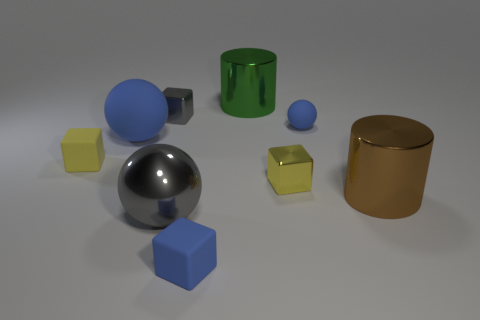Subtract 1 blocks. How many blocks are left? 3 Subtract all cylinders. How many objects are left? 7 Add 9 tiny green metallic blocks. How many tiny green metallic blocks exist? 9 Subtract 1 gray blocks. How many objects are left? 8 Subtract all blue matte things. Subtract all small spheres. How many objects are left? 5 Add 8 big shiny balls. How many big shiny balls are left? 9 